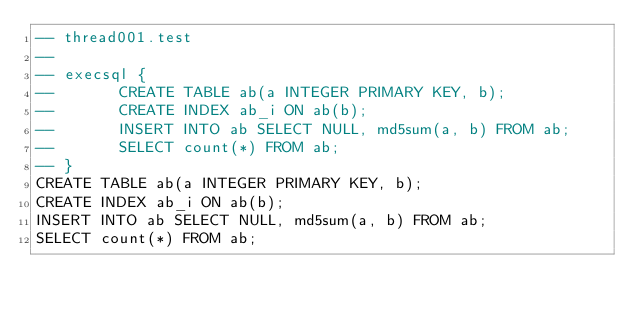<code> <loc_0><loc_0><loc_500><loc_500><_SQL_>-- thread001.test
-- 
-- execsql {
--       CREATE TABLE ab(a INTEGER PRIMARY KEY, b);
--       CREATE INDEX ab_i ON ab(b);
--       INSERT INTO ab SELECT NULL, md5sum(a, b) FROM ab;
--       SELECT count(*) FROM ab;
-- }
CREATE TABLE ab(a INTEGER PRIMARY KEY, b);
CREATE INDEX ab_i ON ab(b);
INSERT INTO ab SELECT NULL, md5sum(a, b) FROM ab;
SELECT count(*) FROM ab;</code> 